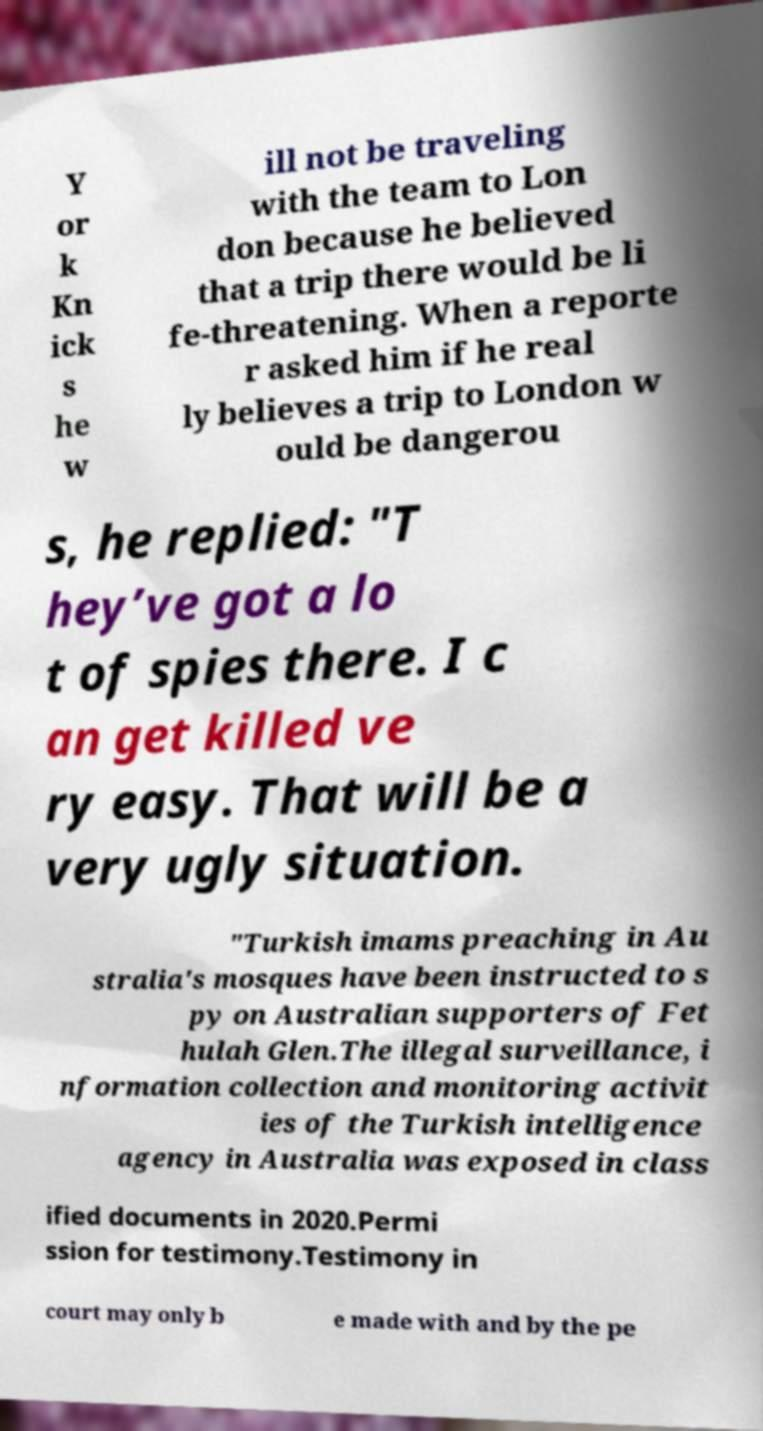Please identify and transcribe the text found in this image. Y or k Kn ick s he w ill not be traveling with the team to Lon don because he believed that a trip there would be li fe-threatening. When a reporte r asked him if he real ly believes a trip to London w ould be dangerou s, he replied: "T hey’ve got a lo t of spies there. I c an get killed ve ry easy. That will be a very ugly situation. "Turkish imams preaching in Au stralia's mosques have been instructed to s py on Australian supporters of Fet hulah Glen.The illegal surveillance, i nformation collection and monitoring activit ies of the Turkish intelligence agency in Australia was exposed in class ified documents in 2020.Permi ssion for testimony.Testimony in court may only b e made with and by the pe 